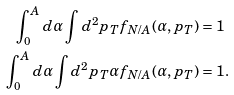<formula> <loc_0><loc_0><loc_500><loc_500>\int _ { 0 } ^ { A } d \alpha \int d ^ { 2 } p _ { T } f _ { N / A } ( \alpha , p _ { T } ) & = 1 \\ \int _ { 0 } ^ { A } d \alpha \int d ^ { 2 } p _ { T } \alpha f _ { N / A } ( \alpha , p _ { T } ) & = 1 .</formula> 